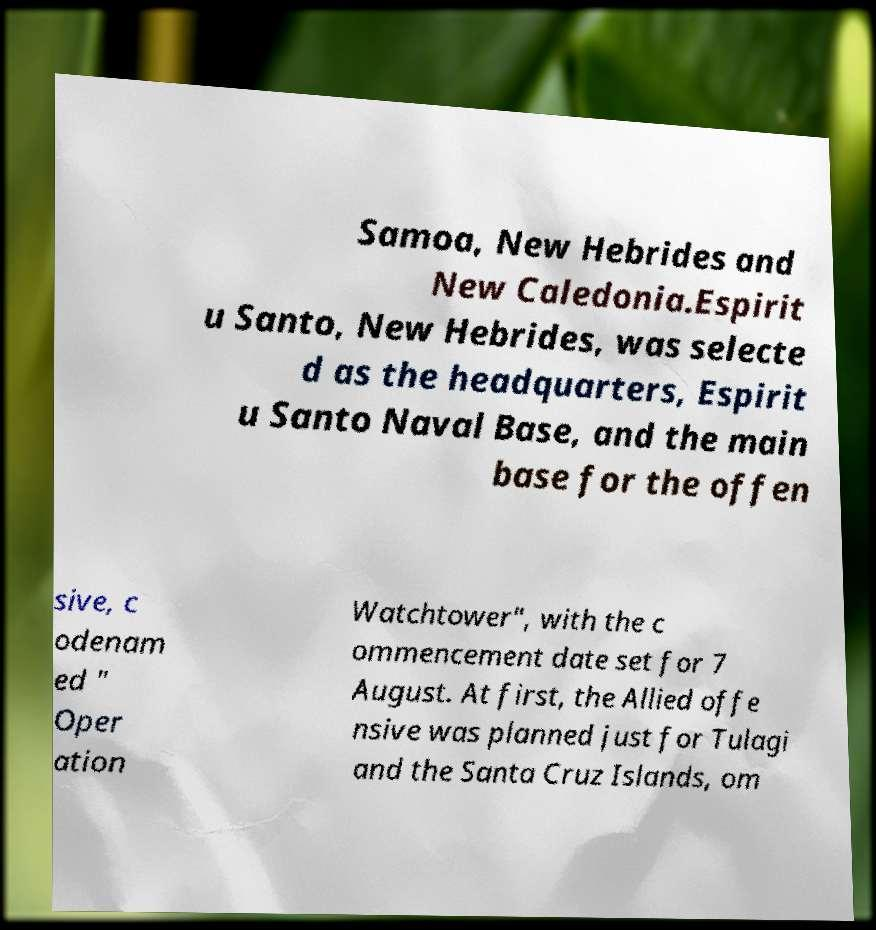Can you accurately transcribe the text from the provided image for me? Samoa, New Hebrides and New Caledonia.Espirit u Santo, New Hebrides, was selecte d as the headquarters, Espirit u Santo Naval Base, and the main base for the offen sive, c odenam ed " Oper ation Watchtower", with the c ommencement date set for 7 August. At first, the Allied offe nsive was planned just for Tulagi and the Santa Cruz Islands, om 